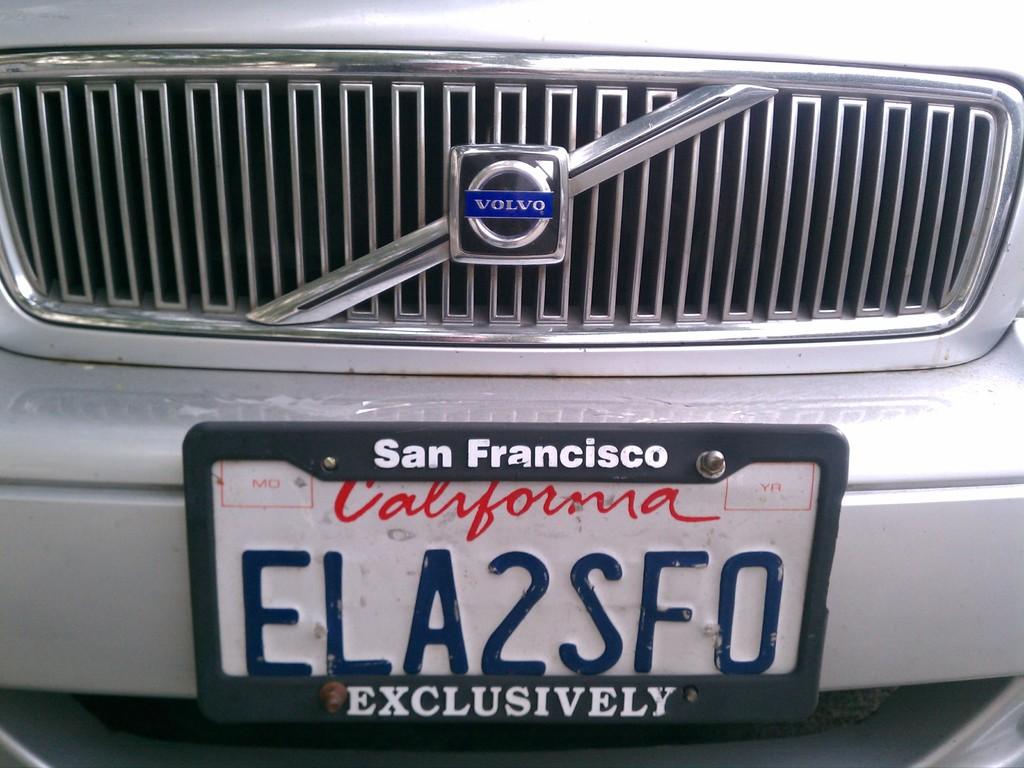What is this cars plate number?
Your answer should be very brief. Ela2sf0. 